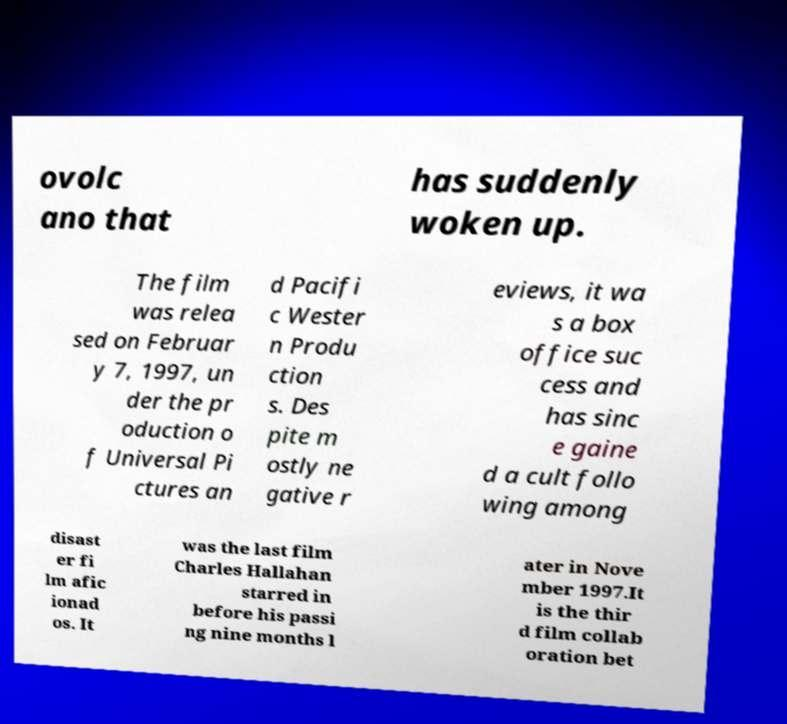Please identify and transcribe the text found in this image. ovolc ano that has suddenly woken up. The film was relea sed on Februar y 7, 1997, un der the pr oduction o f Universal Pi ctures an d Pacifi c Wester n Produ ction s. Des pite m ostly ne gative r eviews, it wa s a box office suc cess and has sinc e gaine d a cult follo wing among disast er fi lm afic ionad os. It was the last film Charles Hallahan starred in before his passi ng nine months l ater in Nove mber 1997.It is the thir d film collab oration bet 